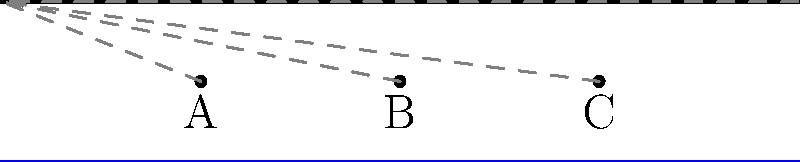As a civil engineer designing a bridge over a river, you need to determine the most efficient layout for the support system. The bridge deck is 100 meters long, and you have three potential support points: A (at 25m), B (at 50m), and C (at 75m). You can use either two or three supports. Which support configuration would provide the most efficient and stable design?

a) A and C
b) A, B, and C
c) A and B
d) B and C To determine the most efficient layout for the bridge support system, we need to consider the following factors:

1. Span length: Shorter spans are generally more stable and require less material.
2. Load distribution: Evenly distributed loads are preferable for structural stability.
3. Number of supports: More supports can increase stability but also increase cost and complexity.

Let's analyze each option:

a) A and C:
   - Two supports, creating a single 50m span
   - Uneven load distribution (25m overhang on one side)

b) A, B, and C:
   - Three supports, creating two 25m spans
   - Even load distribution
   - More supports, potentially increasing cost and complexity

c) A and B:
   - Two supports, creating a 25m span and a 50m overhang
   - Highly uneven load distribution

d) B and C:
   - Two supports, creating a 50m span and a 25m overhang
   - Uneven load distribution (mirror of option c)

Considering these factors, option b (A, B, and C) provides the most efficient and stable design because:

1. It creates two equal 25m spans, which are shorter and more stable than the 50m spans in other options.
2. The load is evenly distributed across the entire bridge length.
3. Although it uses three supports instead of two, the increased stability and even load distribution outweigh the potential increase in cost and complexity.

Therefore, the most efficient layout for the bridge support system is to use all three support points: A, B, and C.
Answer: A, B, and C 